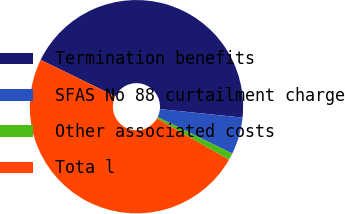Convert chart to OTSL. <chart><loc_0><loc_0><loc_500><loc_500><pie_chart><fcel>Termination benefits<fcel>SFAS No 88 curtailment charge<fcel>Other associated costs<fcel>Tota l<nl><fcel>44.39%<fcel>5.61%<fcel>1.06%<fcel>48.94%<nl></chart> 